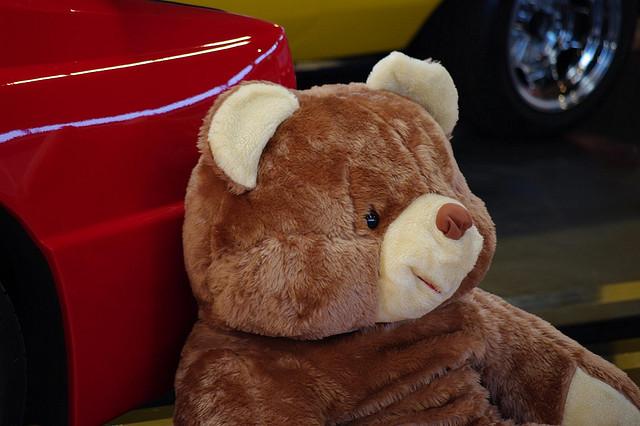What color is the animal's nose?
Give a very brief answer. Brown. Is this teddy bear wearing clothing?
Give a very brief answer. No. Is the bear brand new?
Short answer required. Yes. Is this a kitten?
Be succinct. No. What shape is behind the bear?
Answer briefly. Car. What color is the car left of the bear?
Be succinct. Red. How many vehicles are in back of the bear?
Give a very brief answer. 2. Is the teddy bear covered one eye with a colorful ribbon?
Short answer required. No. What kind of animal is this?
Be succinct. Teddy bear. What color is the teddy bears nose?
Give a very brief answer. Brown. What is on the bear's ear?
Give a very brief answer. Nothing. How many teddy bears are shown?
Quick response, please. 1. What color is the bow on the teddy bear?
Keep it brief. No bow. How many eyes does the bear have?
Concise answer only. 1. 